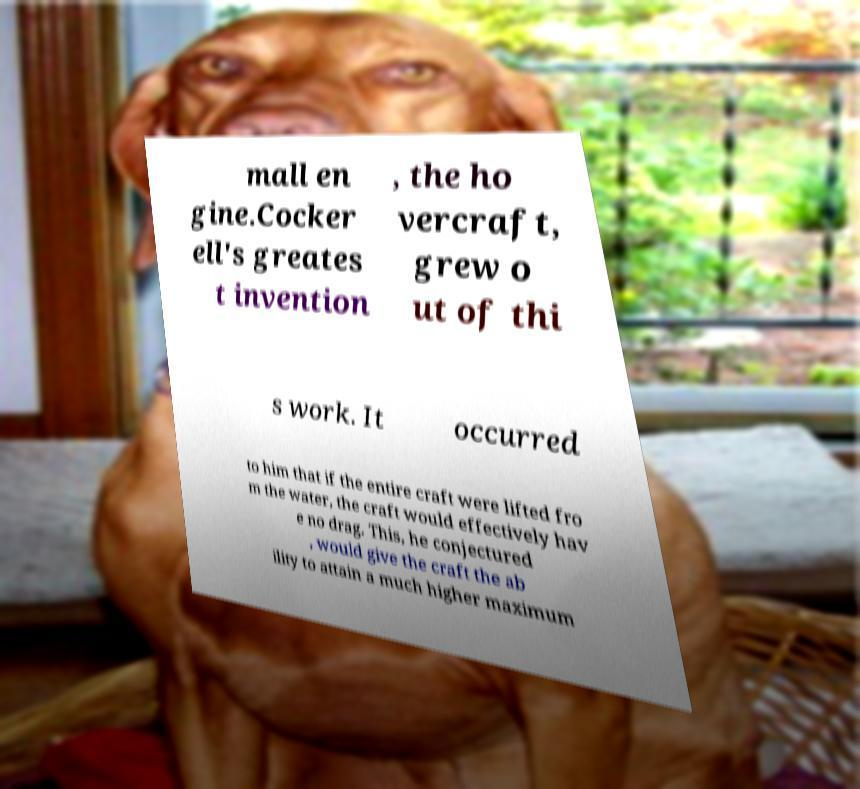Please read and relay the text visible in this image. What does it say? mall en gine.Cocker ell's greates t invention , the ho vercraft, grew o ut of thi s work. It occurred to him that if the entire craft were lifted fro m the water, the craft would effectively hav e no drag. This, he conjectured , would give the craft the ab ility to attain a much higher maximum 